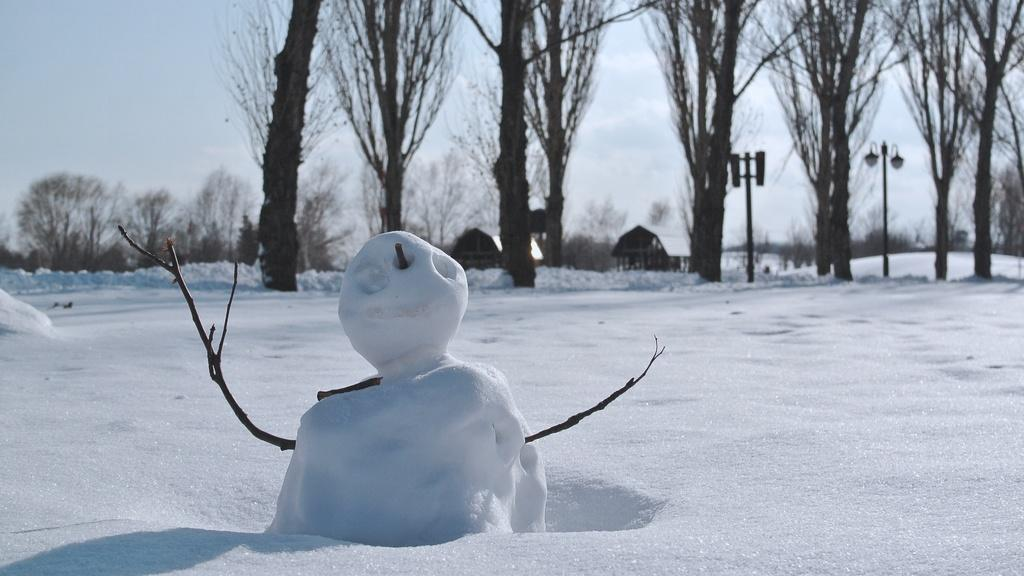What is the main subject of the image? There is a snowman in the image. What type of weather is depicted in the image? There is snow in the image. What type of vegetation can be seen in the image? There are trees in the image. What type of structures are visible in the background of the image? There are small houses in the background of the image. What type of man-made object is present in the image? There is a light pole in the image. What is visible in the sky in the image? The sky is visible in the image. How many branches are attached to the snowman in the image? There are no branches attached to the snowman in the image, as it is a snowman and not a tree or plant. 